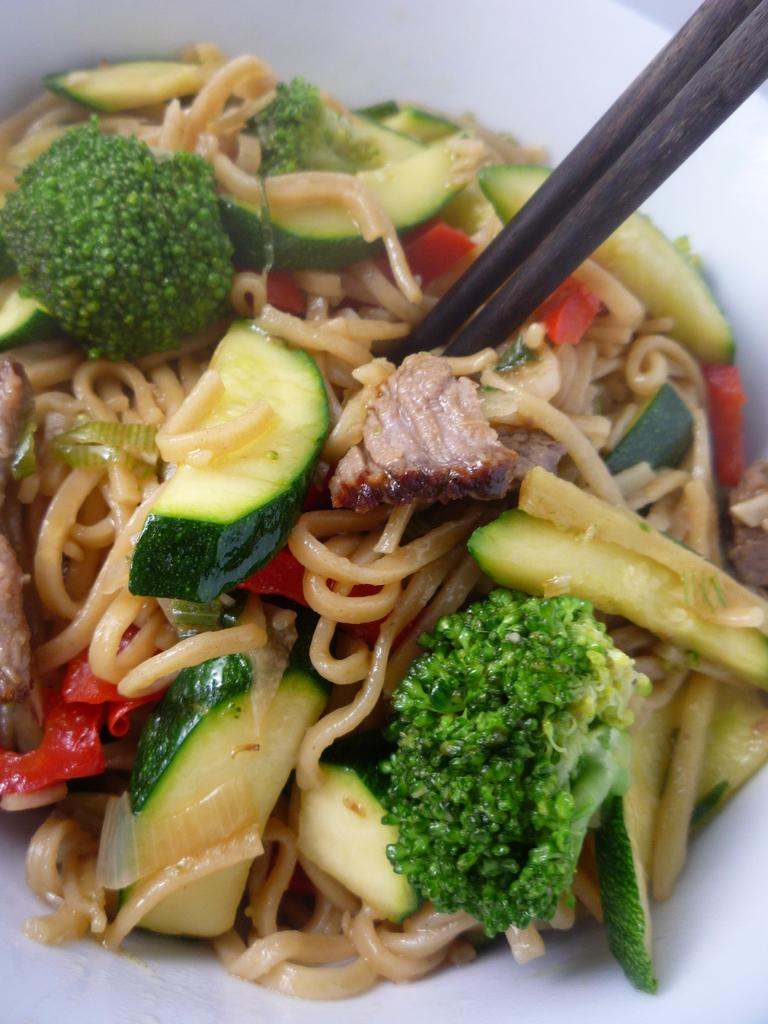What can be seen in the image related to food? There is food in the image, including food items placed on a plate. Can you identify any specific food items on the plate? Yes, broccoli is present in the plate. How many horses can be seen grazing in the background of the image? There are no horses present in the image; it features food items on a plate. 